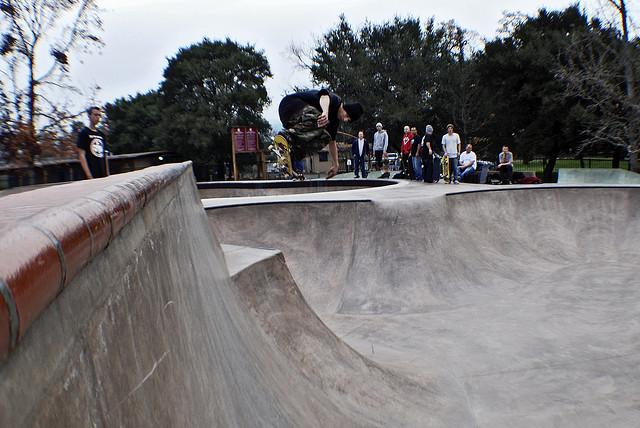Who is wearing a blue shirt?
Be succinct. Man. How many females are in this picture?
Be succinct. 0. How many people are playing?
Be succinct. 1. Is everyone interested in the performance?
Quick response, please. Yes. What is the difficulty level of the skate park?
Short answer required. Hard. 